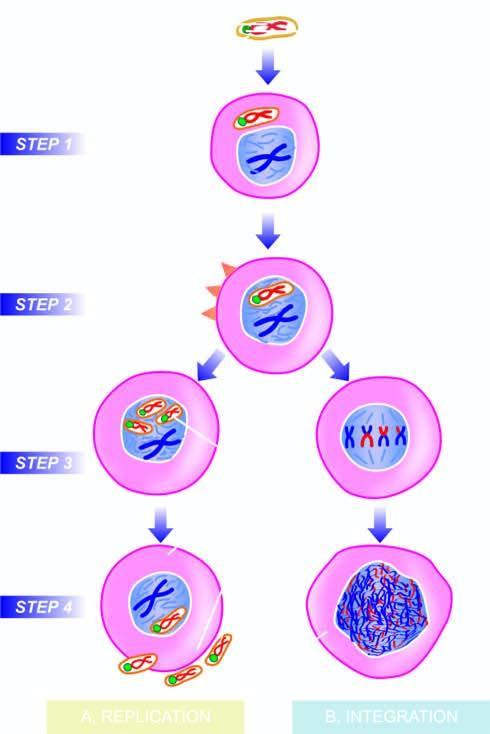what does the dna virus invade?
Answer the question using a single word or phrase. The host cell 